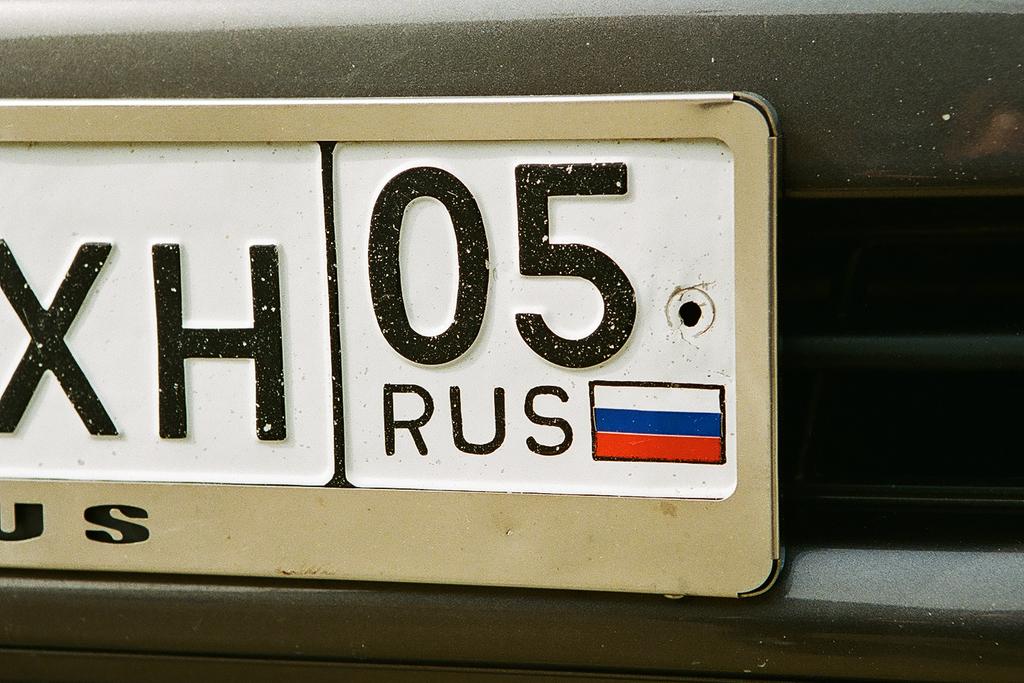What abbreviated country name is shown on this license plate?
Offer a terse response. Rus. This is mobile display?
Ensure brevity in your answer.  No. 